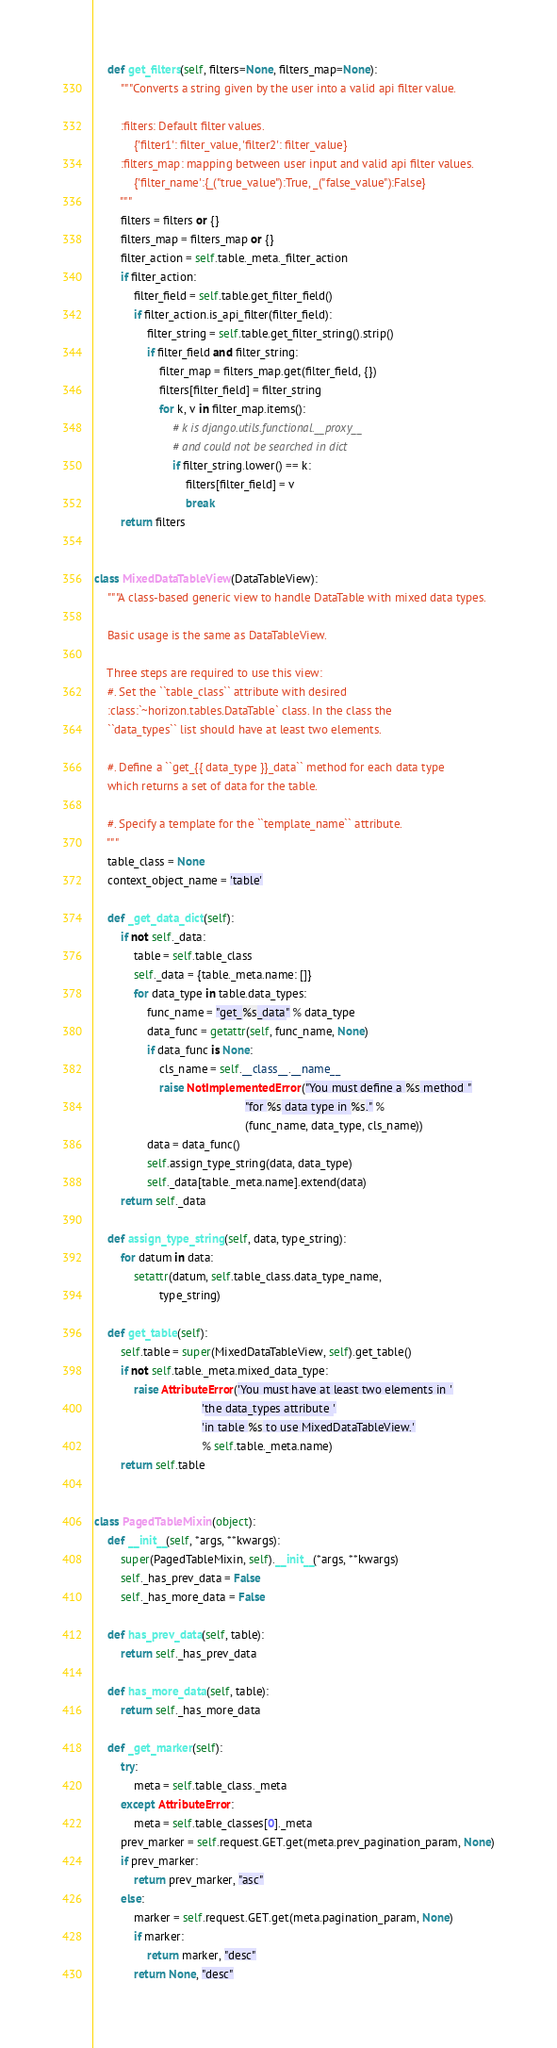Convert code to text. <code><loc_0><loc_0><loc_500><loc_500><_Python_>    def get_filters(self, filters=None, filters_map=None):
        """Converts a string given by the user into a valid api filter value.

        :filters: Default filter values.
            {'filter1': filter_value, 'filter2': filter_value}
        :filters_map: mapping between user input and valid api filter values.
            {'filter_name':{_("true_value"):True, _("false_value"):False}
        """
        filters = filters or {}
        filters_map = filters_map or {}
        filter_action = self.table._meta._filter_action
        if filter_action:
            filter_field = self.table.get_filter_field()
            if filter_action.is_api_filter(filter_field):
                filter_string = self.table.get_filter_string().strip()
                if filter_field and filter_string:
                    filter_map = filters_map.get(filter_field, {})
                    filters[filter_field] = filter_string
                    for k, v in filter_map.items():
                        # k is django.utils.functional.__proxy__
                        # and could not be searched in dict
                        if filter_string.lower() == k:
                            filters[filter_field] = v
                            break
        return filters


class MixedDataTableView(DataTableView):
    """A class-based generic view to handle DataTable with mixed data types.

    Basic usage is the same as DataTableView.

    Three steps are required to use this view:
    #. Set the ``table_class`` attribute with desired
    :class:`~horizon.tables.DataTable` class. In the class the
    ``data_types`` list should have at least two elements.

    #. Define a ``get_{{ data_type }}_data`` method for each data type
    which returns a set of data for the table.

    #. Specify a template for the ``template_name`` attribute.
    """
    table_class = None
    context_object_name = 'table'

    def _get_data_dict(self):
        if not self._data:
            table = self.table_class
            self._data = {table._meta.name: []}
            for data_type in table.data_types:
                func_name = "get_%s_data" % data_type
                data_func = getattr(self, func_name, None)
                if data_func is None:
                    cls_name = self.__class__.__name__
                    raise NotImplementedError("You must define a %s method "
                                              "for %s data type in %s." %
                                              (func_name, data_type, cls_name))
                data = data_func()
                self.assign_type_string(data, data_type)
                self._data[table._meta.name].extend(data)
        return self._data

    def assign_type_string(self, data, type_string):
        for datum in data:
            setattr(datum, self.table_class.data_type_name,
                    type_string)

    def get_table(self):
        self.table = super(MixedDataTableView, self).get_table()
        if not self.table._meta.mixed_data_type:
            raise AttributeError('You must have at least two elements in '
                                 'the data_types attribute '
                                 'in table %s to use MixedDataTableView.'
                                 % self.table._meta.name)
        return self.table


class PagedTableMixin(object):
    def __init__(self, *args, **kwargs):
        super(PagedTableMixin, self).__init__(*args, **kwargs)
        self._has_prev_data = False
        self._has_more_data = False

    def has_prev_data(self, table):
        return self._has_prev_data

    def has_more_data(self, table):
        return self._has_more_data

    def _get_marker(self):
        try:
            meta = self.table_class._meta
        except AttributeError:
            meta = self.table_classes[0]._meta
        prev_marker = self.request.GET.get(meta.prev_pagination_param, None)
        if prev_marker:
            return prev_marker, "asc"
        else:
            marker = self.request.GET.get(meta.pagination_param, None)
            if marker:
                return marker, "desc"
            return None, "desc"
</code> 